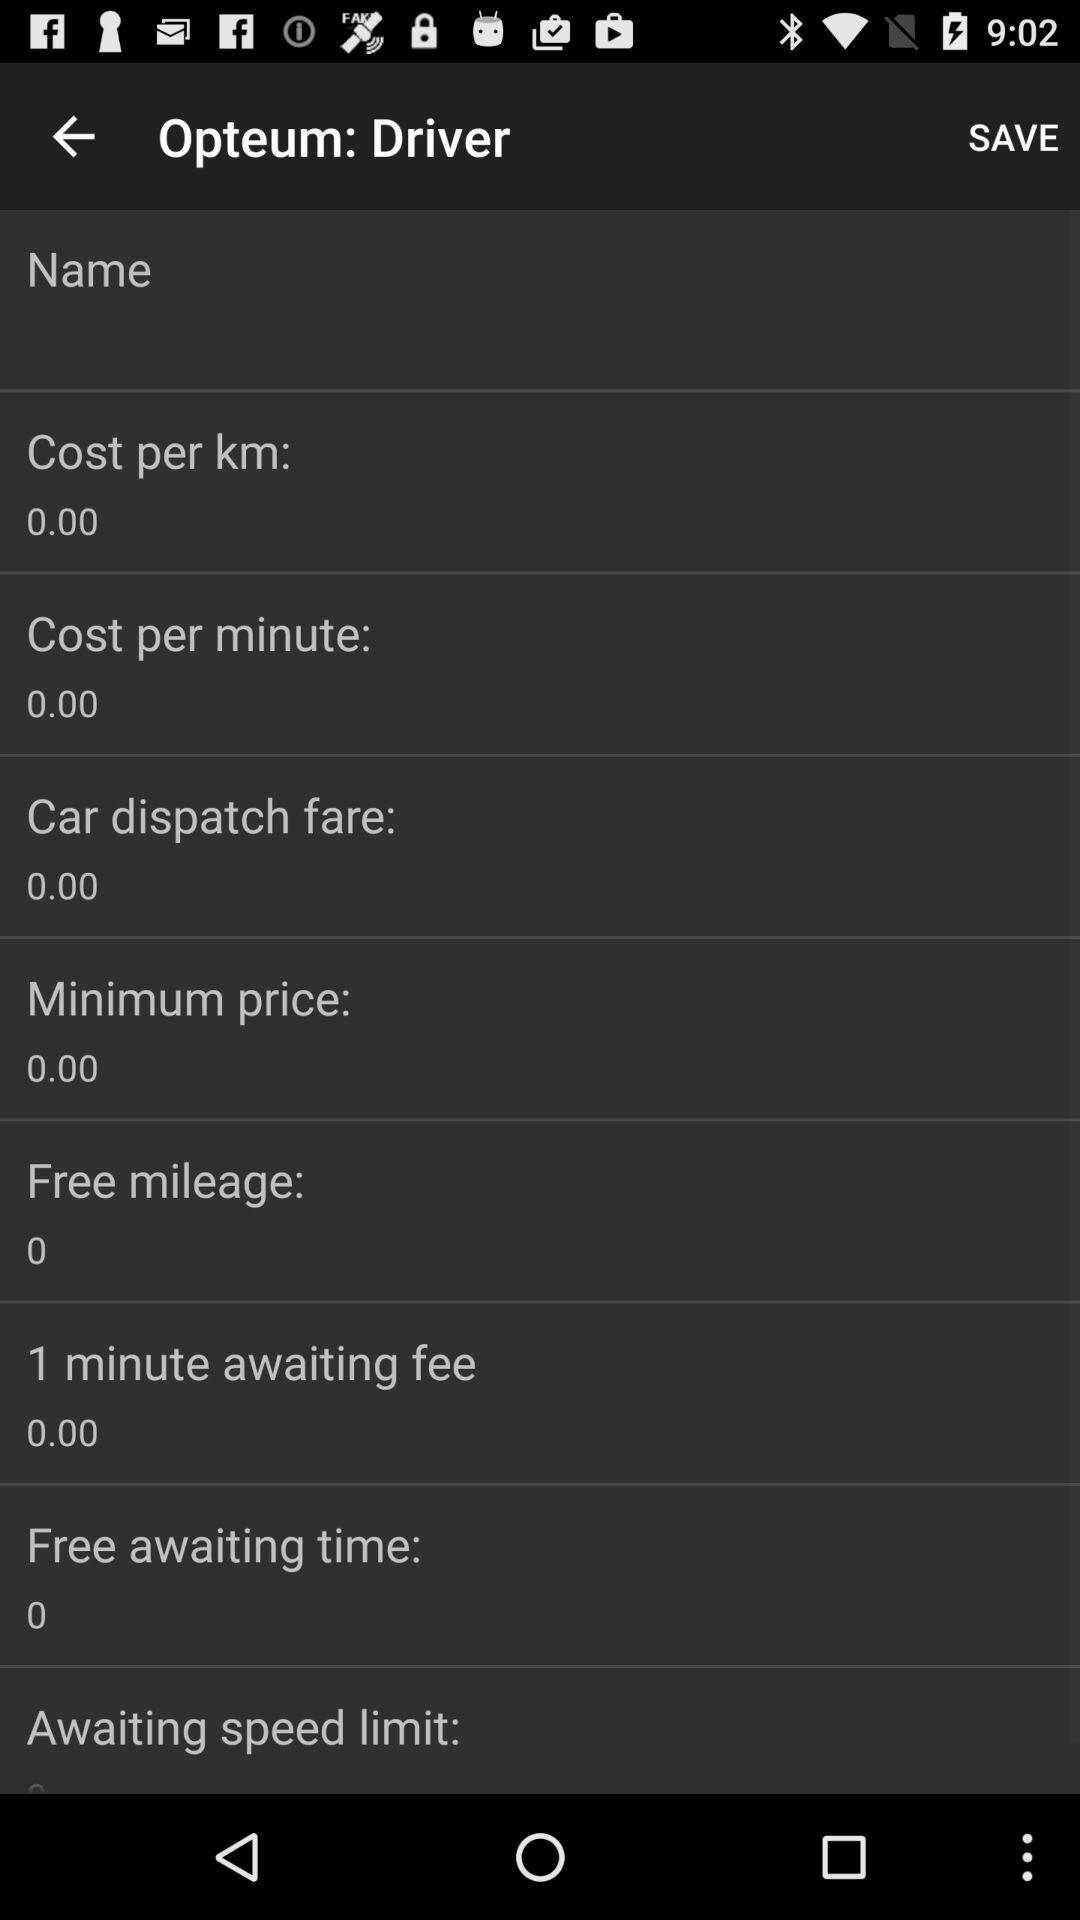How much is the "Free mileage"? The "Free mileage" is 0. 